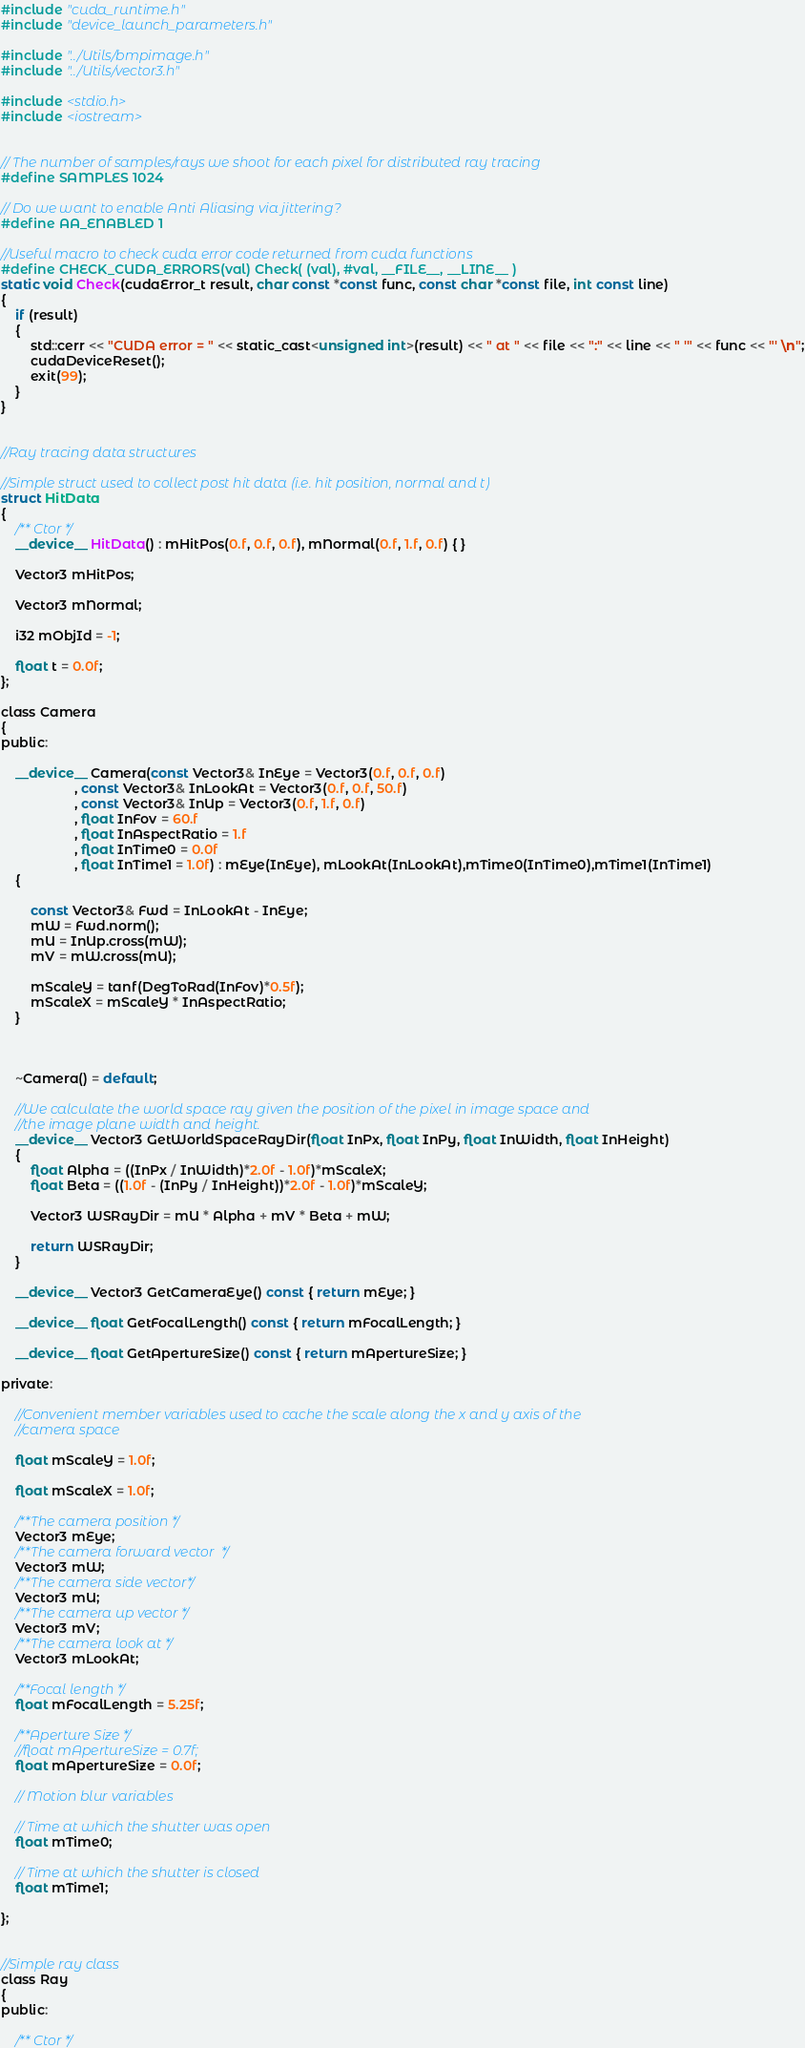Convert code to text. <code><loc_0><loc_0><loc_500><loc_500><_Cuda_>#include "cuda_runtime.h"
#include "device_launch_parameters.h"

#include "../Utils/bmpimage.h"
#include "../Utils/vector3.h"

#include <stdio.h>
#include <iostream>


// The number of samples/rays we shoot for each pixel for distributed ray tracing
#define SAMPLES 1024

// Do we want to enable Anti Aliasing via jittering?
#define AA_ENABLED 1

//Useful macro to check cuda error code returned from cuda functions
#define CHECK_CUDA_ERRORS(val) Check( (val), #val, __FILE__, __LINE__ )
static void Check(cudaError_t result, char const *const func, const char *const file, int const line)
{
	if (result)
	{
		std::cerr << "CUDA error = " << static_cast<unsigned int>(result) << " at " << file << ":" << line << " '" << func << "' \n";
		cudaDeviceReset();
		exit(99);
	}
}


//Ray tracing data structures

//Simple struct used to collect post hit data (i.e. hit position, normal and t)
struct HitData
{
	/** Ctor */
	__device__ HitData() : mHitPos(0.f, 0.f, 0.f), mNormal(0.f, 1.f, 0.f) { }

	Vector3 mHitPos;

	Vector3 mNormal;

	i32 mObjId = -1;

	float t = 0.0f;
};

class Camera
{
public:

	__device__ Camera(const Vector3& InEye = Vector3(0.f, 0.f, 0.f)
		            , const Vector3& InLookAt = Vector3(0.f, 0.f, 50.f)
		            , const Vector3& InUp = Vector3(0.f, 1.f, 0.f)
		            , float InFov = 60.f
		            , float InAspectRatio = 1.f
	                , float InTime0 = 0.0f
	                , float InTime1 = 1.0f) : mEye(InEye), mLookAt(InLookAt),mTime0(InTime0),mTime1(InTime1)
	{

		const Vector3& Fwd = InLookAt - InEye;
		mW = Fwd.norm();
		mU = InUp.cross(mW);
		mV = mW.cross(mU);

		mScaleY = tanf(DegToRad(InFov)*0.5f);
		mScaleX = mScaleY * InAspectRatio;
	}



	~Camera() = default;

	//We calculate the world space ray given the position of the pixel in image space and 
	//the image plane width and height.
	__device__ Vector3 GetWorldSpaceRayDir(float InPx, float InPy, float InWidth, float InHeight)
	{
		float Alpha = ((InPx / InWidth)*2.0f - 1.0f)*mScaleX;
		float Beta = ((1.0f - (InPy / InHeight))*2.0f - 1.0f)*mScaleY;

		Vector3 WSRayDir = mU * Alpha + mV * Beta + mW;

		return WSRayDir;
	}

	__device__ Vector3 GetCameraEye() const { return mEye; }

	__device__ float GetFocalLength() const { return mFocalLength; }

	__device__ float GetApertureSize() const { return mApertureSize; }

private:

	//Convenient member variables used to cache the scale along the x and y axis of the
	//camera space

	float mScaleY = 1.0f;

	float mScaleX = 1.0f;

	/**The camera position */
	Vector3 mEye;
	/**The camera forward vector  */
	Vector3 mW;
	/**The camera side vector*/
	Vector3 mU;
	/**The camera up vector */
	Vector3 mV;
	/**The camera look at */
	Vector3 mLookAt;

	/**Focal length */
	float mFocalLength = 5.25f;

	/**Aperture Size */
	//float mApertureSize = 0.7f;
	float mApertureSize = 0.0f;

	// Motion blur variables

	// Time at which the shutter was open
	float mTime0;

	// Time at which the shutter is closed
	float mTime1;

};


//Simple ray class 
class Ray
{
public:

	/** Ctor */</code> 